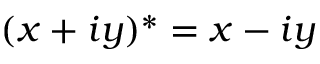Convert formula to latex. <formula><loc_0><loc_0><loc_500><loc_500>( x + i y ) ^ { * } = x - i y</formula> 